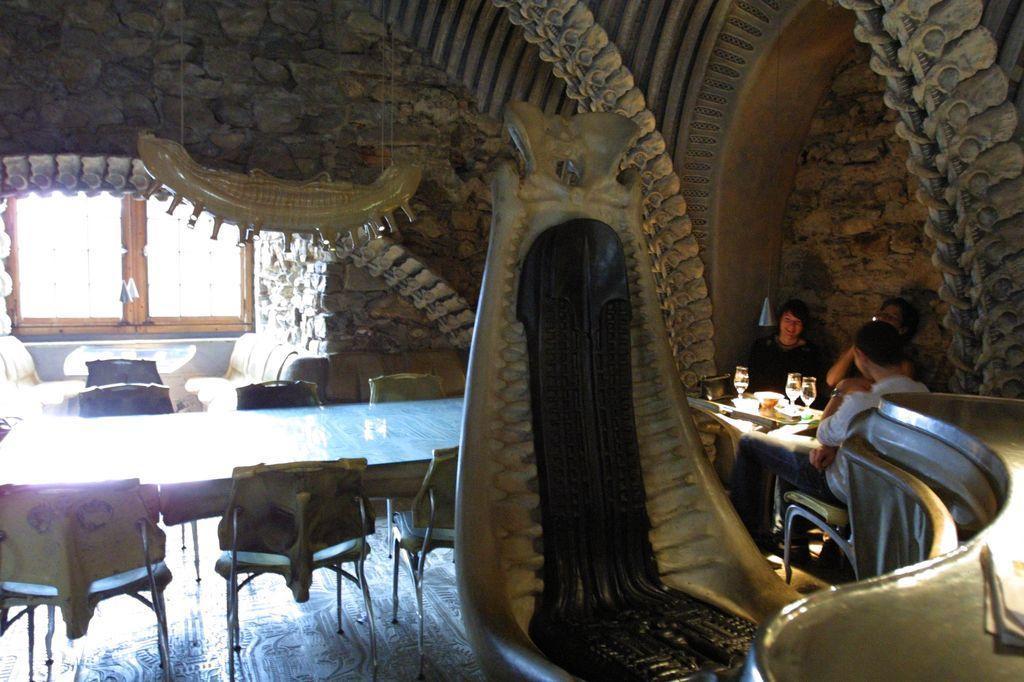Please provide a concise description of this image. In this room there are chairs,tables and a window. On the right there are 3 people sitting on the chair at the table. On the table there are glasses and food items. 